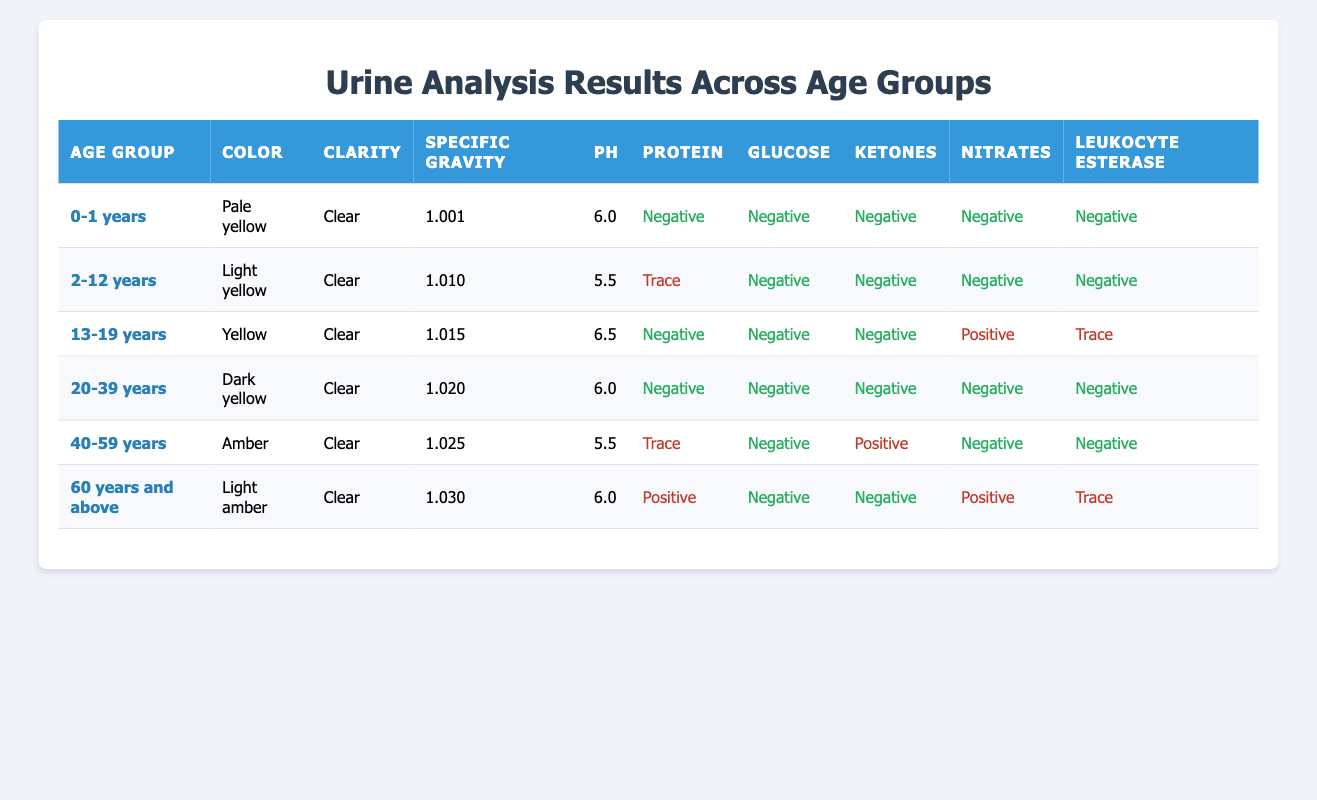What is the specific gravity of the urine analysis results for the age group 2-12 years? The specific gravity for the age group 2-12 years is found in the corresponding row under the "Specific Gravity" column, which shows a value of 1.010.
Answer: 1.010 Which age group reports a pH value of 5.5? The age groups listed are checked one by one to find the corresponding pH value. Both the age groups 2-12 years and 40-59 years show a pH of 5.5.
Answer: 2-12 years and 40-59 years Is the result for leukocyte esterase positive in the age group 0-1 years? Reviewing the "Leukocyte Esterase" column for the age group 0-1 years indicates a value of "Negative." Therefore, it is not positive.
Answer: No What is the average specific gravity of the age groups that have a "Trace" result for protein? The age groups with "Trace" results for protein are 2-12 years and 40-59 years. Their specific gravities are 1.010 and 1.025, respectively. The average is (1.010 + 1.025)/2 = 1.0175.
Answer: 1.0175 Does the age group 60 years and above have a positive result for both ketones and nitrates? Looking at the data specifically for the age group 60 years and above, the ketones are "Negative" and the nitrates are "Positive." This means it does not have a positive result for both.
Answer: No Which age group has the highest specific gravity and what is that value? By comparing the "Specific Gravity" values across all age groups, the highest value is for the age group 60 years and above, which is 1.030.
Answer: 60 years and above, 1.030 How many age groups show a negative result for ketones? To find this, we examine each age group's ketone results. The age groups 0-1 years, 2-12 years, 13-19 years, 20-39 years, and 60 years and above show "Negative" results, totaling 5 age groups.
Answer: 5 What is the difference in specific gravity between the age groups of 20-39 years and 40-59 years? The specific gravity for the 20-39 years age group is 1.020 and for 40-59 years it is 1.025. The difference is calculated as 1.025 - 1.020 = 0.005.
Answer: 0.005 Are protein results negative for all age groups below 40 years? Checking the protein results for the age groups 0-1 years (Negative), 2-12 years (Trace), 13-19 years (Negative), and 20-39 years (Negative), shows that not all are negative (specifically, 2-12 years has a Trace).
Answer: No 